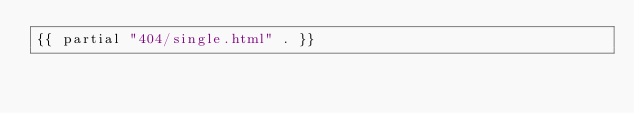Convert code to text. <code><loc_0><loc_0><loc_500><loc_500><_HTML_>{{ partial "404/single.html" . }}

</code> 